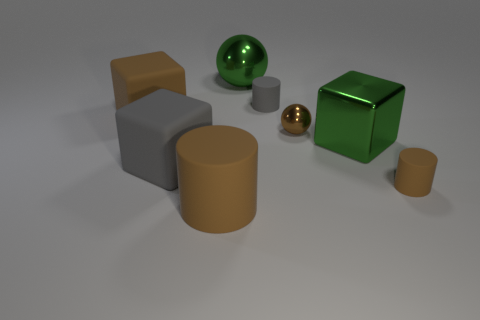How many brown cylinders must be subtracted to get 1 brown cylinders? 1 Subtract all gray matte blocks. How many blocks are left? 2 Subtract all brown blocks. How many blocks are left? 2 Add 1 large cyan rubber cubes. How many objects exist? 9 Subtract all cylinders. How many objects are left? 5 Subtract all yellow balls. How many red blocks are left? 0 Subtract all tiny blue rubber cylinders. Subtract all brown blocks. How many objects are left? 7 Add 7 brown metal balls. How many brown metal balls are left? 8 Add 6 green objects. How many green objects exist? 8 Subtract 0 red cylinders. How many objects are left? 8 